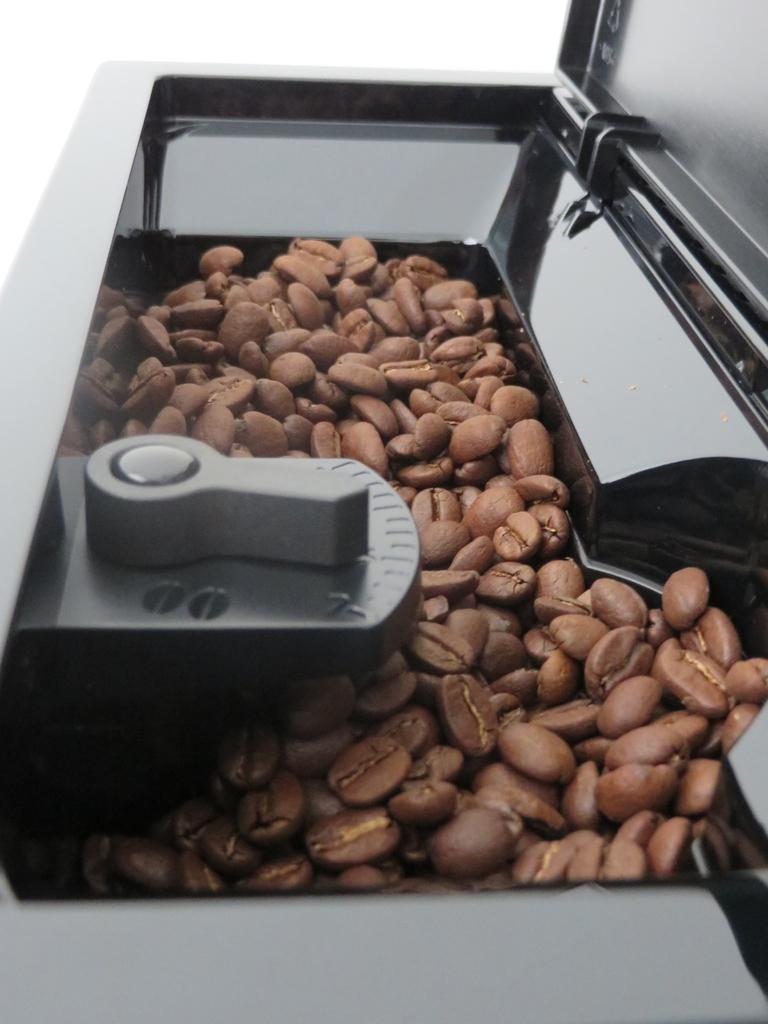What is the main subject of the image? The main subject of the image is coffee seeds. Where are the coffee seeds located? The coffee seeds are in a container. Can you tell me how many desks are visible in the image? There are no desks present in the image; it features coffee seeds in a container. What type of liquid is being poured from the container in the image? There is no liquid being poured in the image; it features coffee seeds in a container. 